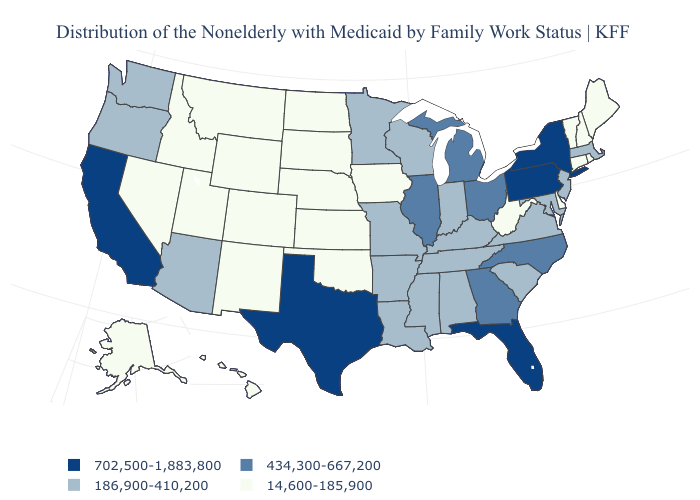Among the states that border Nevada , which have the highest value?
Write a very short answer. California. What is the value of Tennessee?
Be succinct. 186,900-410,200. Among the states that border Nevada , does Oregon have the lowest value?
Be succinct. No. Does Maryland have the same value as New Hampshire?
Give a very brief answer. No. Name the states that have a value in the range 702,500-1,883,800?
Give a very brief answer. California, Florida, New York, Pennsylvania, Texas. Name the states that have a value in the range 14,600-185,900?
Write a very short answer. Alaska, Colorado, Connecticut, Delaware, Hawaii, Idaho, Iowa, Kansas, Maine, Montana, Nebraska, Nevada, New Hampshire, New Mexico, North Dakota, Oklahoma, Rhode Island, South Dakota, Utah, Vermont, West Virginia, Wyoming. Does the first symbol in the legend represent the smallest category?
Be succinct. No. How many symbols are there in the legend?
Keep it brief. 4. Name the states that have a value in the range 186,900-410,200?
Be succinct. Alabama, Arizona, Arkansas, Indiana, Kentucky, Louisiana, Maryland, Massachusetts, Minnesota, Mississippi, Missouri, New Jersey, Oregon, South Carolina, Tennessee, Virginia, Washington, Wisconsin. What is the highest value in the USA?
Be succinct. 702,500-1,883,800. What is the highest value in the South ?
Concise answer only. 702,500-1,883,800. Name the states that have a value in the range 186,900-410,200?
Give a very brief answer. Alabama, Arizona, Arkansas, Indiana, Kentucky, Louisiana, Maryland, Massachusetts, Minnesota, Mississippi, Missouri, New Jersey, Oregon, South Carolina, Tennessee, Virginia, Washington, Wisconsin. Among the states that border Rhode Island , does Connecticut have the lowest value?
Keep it brief. Yes. Does Nebraska have the lowest value in the MidWest?
Answer briefly. Yes. What is the value of Rhode Island?
Answer briefly. 14,600-185,900. 